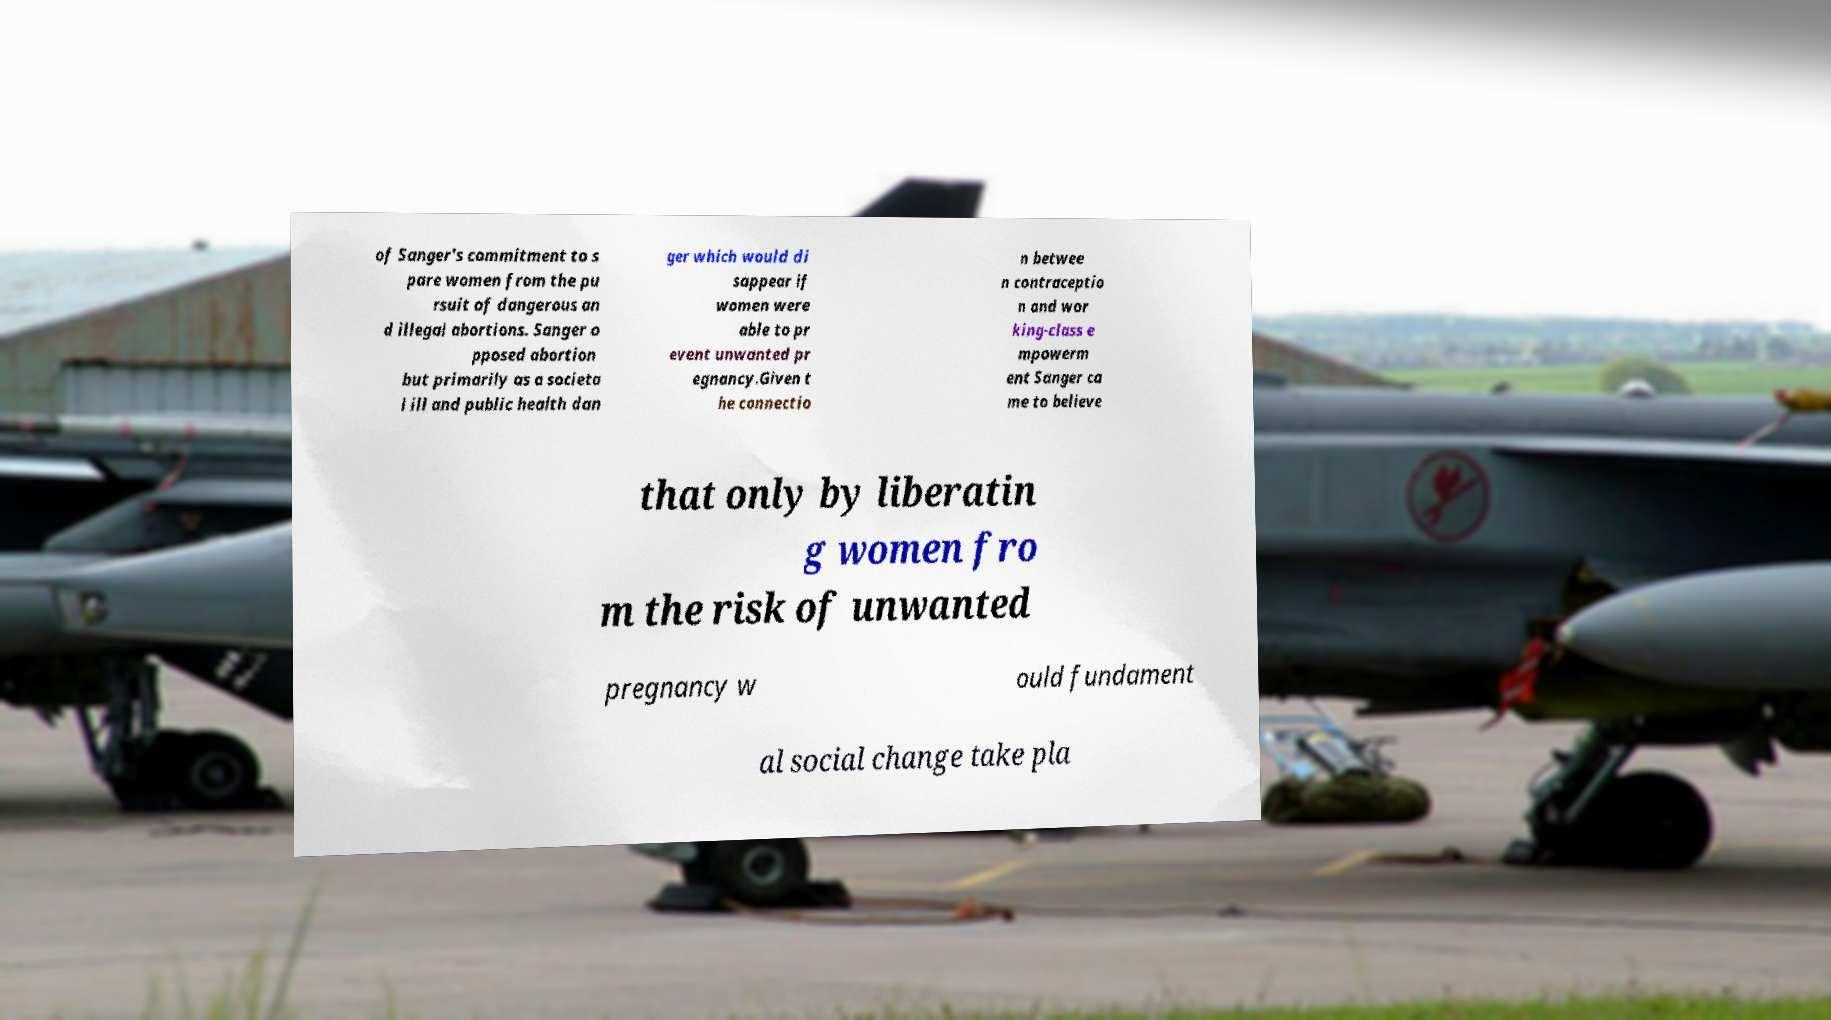There's text embedded in this image that I need extracted. Can you transcribe it verbatim? of Sanger's commitment to s pare women from the pu rsuit of dangerous an d illegal abortions. Sanger o pposed abortion but primarily as a societa l ill and public health dan ger which would di sappear if women were able to pr event unwanted pr egnancy.Given t he connectio n betwee n contraceptio n and wor king-class e mpowerm ent Sanger ca me to believe that only by liberatin g women fro m the risk of unwanted pregnancy w ould fundament al social change take pla 